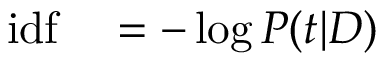<formula> <loc_0><loc_0><loc_500><loc_500>\begin{array} { r l } { i d f } & = - \log P ( t | D ) } \end{array}</formula> 